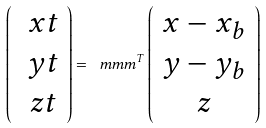Convert formula to latex. <formula><loc_0><loc_0><loc_500><loc_500>\left ( \begin{array} { c } \ x t \\ \ y t \\ \ z t \\ \end{array} \right ) = \ m m m ^ { T } \left ( \begin{array} { c } x - x _ { b } \\ y - y _ { b } \\ z \end{array} \right )</formula> 